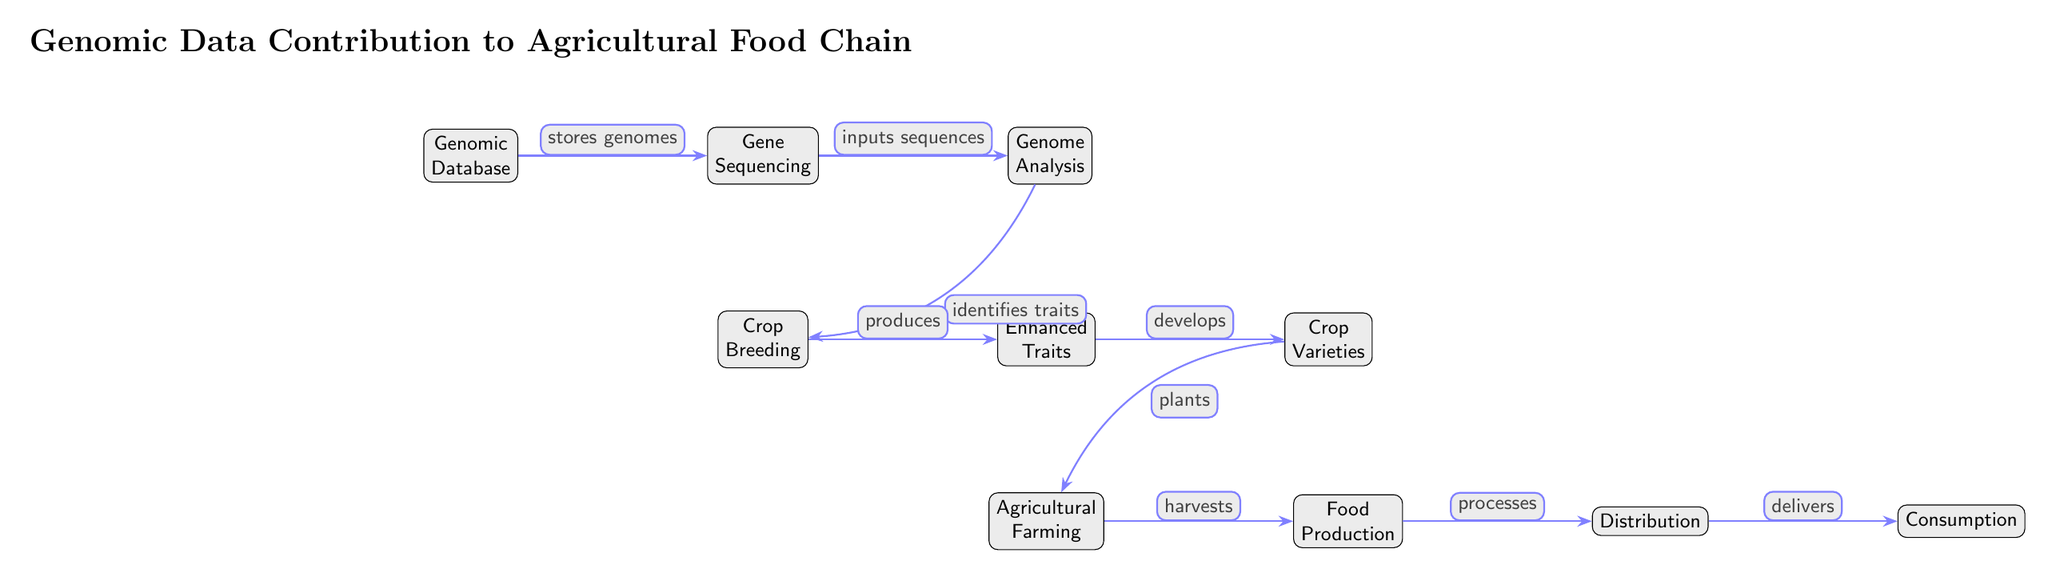What is the first node in the diagram? The first node in the diagram represents the starting point of the food chain and is labeled "Genomic Database."
Answer: Genomic Database What node follows "Gene Sequencing"? The node that follows "Gene Sequencing" in the diagram is labeled "Genome Analysis."
Answer: Genome Analysis How many nodes are there in the diagram? By counting each distinct labeled node in the diagram, there are a total of 9 nodes including the starting and final nodes.
Answer: 9 What relationship does "Genome Analysis" have with "Crop Breeding"? The relationship is described by the phrase "identifies traits," indicating that Genome Analysis helps discover traits that can be useful in Crop Breeding.
Answer: identifies traits Which node is the final step in the food chain? The final step in the food chain represented in the diagram is labeled "Consumption."
Answer: Consumption What is produced from "Crop Breeding"? The output from "Crop Breeding" in the diagram is "Enhanced Traits," which is the next node in the sequence.
Answer: Enhanced Traits What are "Crop Varieties" derived from? The node "Crop Varieties" is derived from "Enhanced Traits," which produces them as an outcome of the previous step.
Answer: Enhanced Traits Which node indicates the process of bringing food to people? The node that indicates the process of bringing food to people is labeled "Distribution," showcasing the phase after food production.
Answer: Distribution What actions are represented from "Agricultural Farming" to "Food Production"? The action represented between these two nodes is "harvests," showing the transition from cultivation to the next stage of food output.
Answer: harvests 